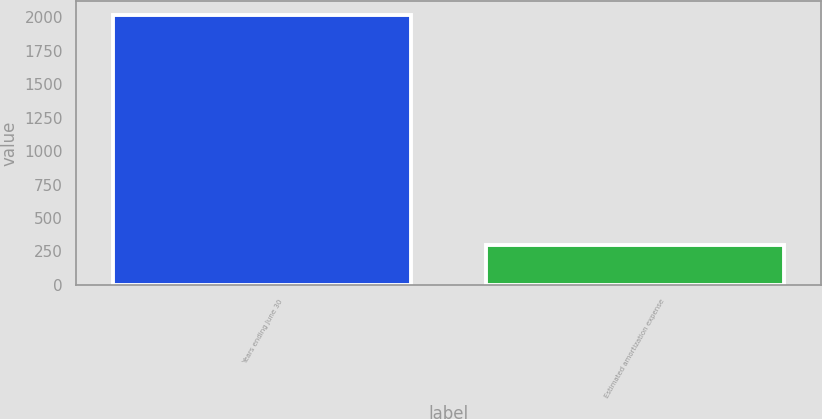<chart> <loc_0><loc_0><loc_500><loc_500><bar_chart><fcel>Years ending June 30<fcel>Estimated amortization expense<nl><fcel>2018<fcel>298<nl></chart> 